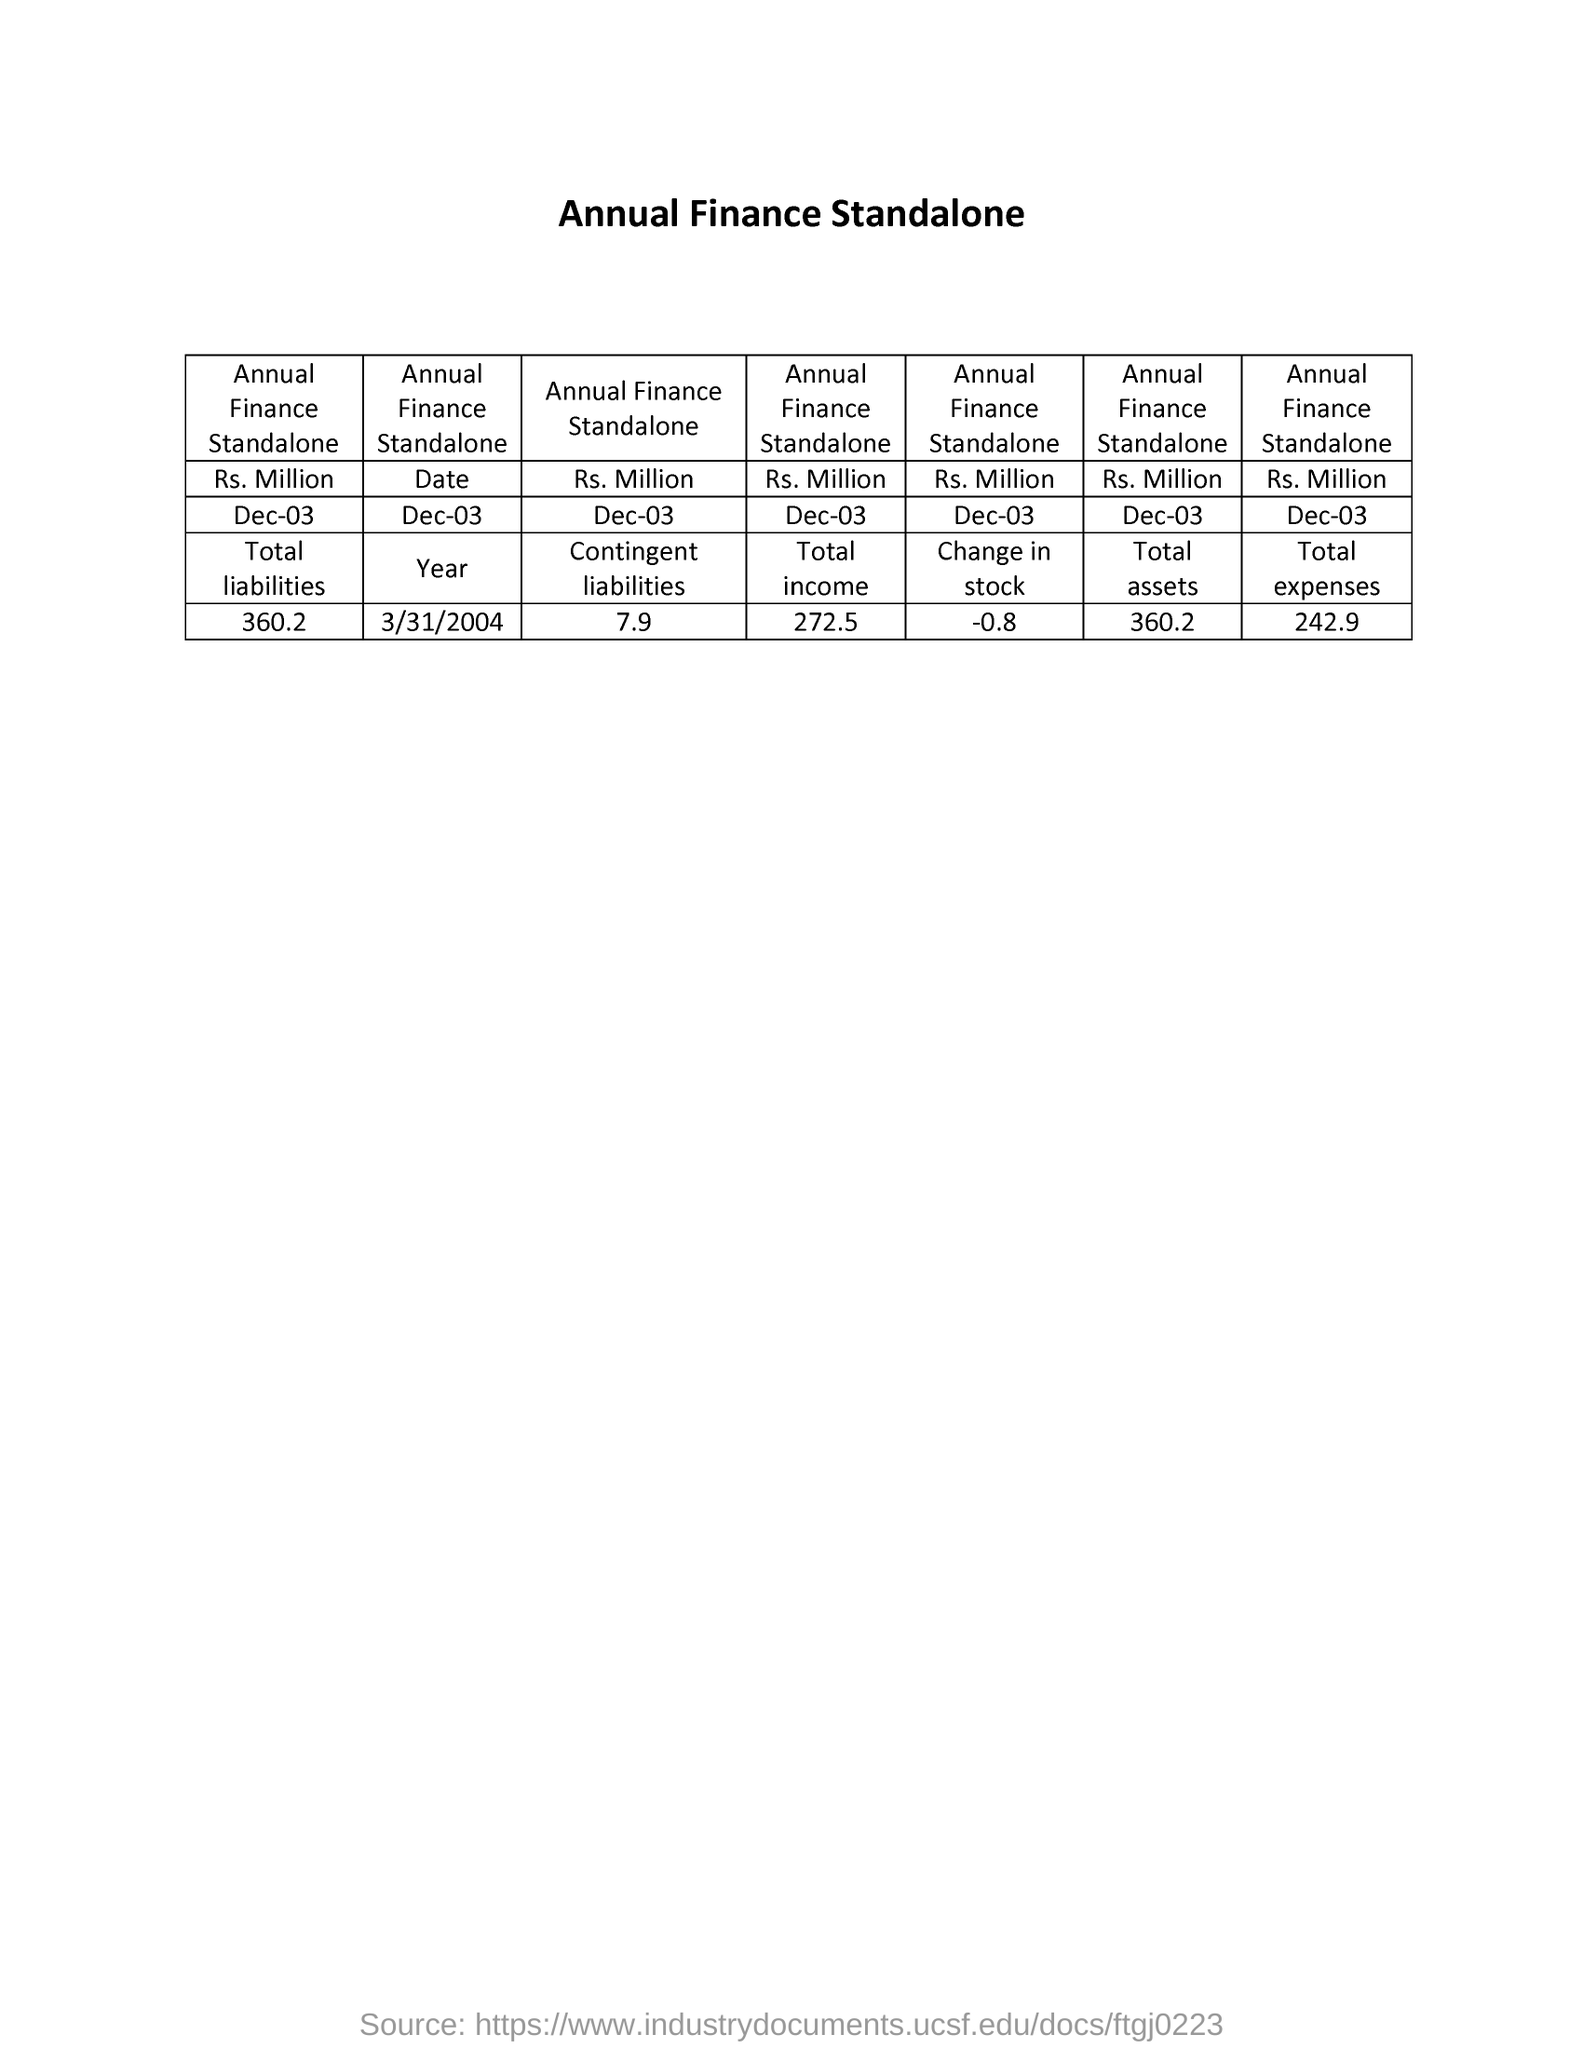What is the title of the document?
Give a very brief answer. Annual Finance Standalone. What is the total expense?
Give a very brief answer. 242.9. What is the total liability?
Give a very brief answer. 360.2. What is the total income?
Your response must be concise. 272.5. What is the total asset?
Your answer should be compact. 360.2. 